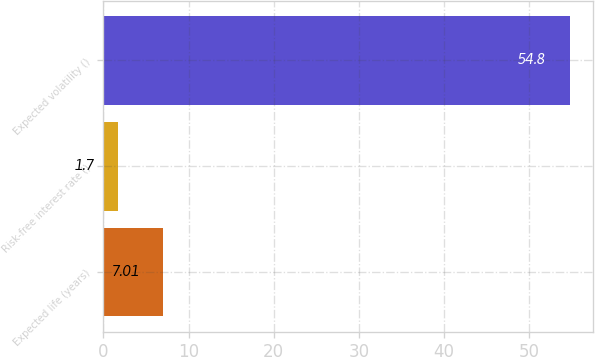Convert chart. <chart><loc_0><loc_0><loc_500><loc_500><bar_chart><fcel>Expected life (years)<fcel>Risk-free interest rate ()<fcel>Expected volatility ()<nl><fcel>7.01<fcel>1.7<fcel>54.8<nl></chart> 